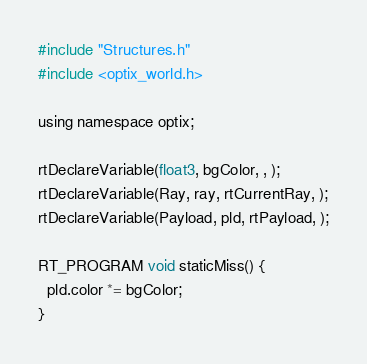<code> <loc_0><loc_0><loc_500><loc_500><_Cuda_>#include "Structures.h"
#include <optix_world.h>

using namespace optix;

rtDeclareVariable(float3, bgColor, , );
rtDeclareVariable(Ray, ray, rtCurrentRay, );
rtDeclareVariable(Payload, pld, rtPayload, );

RT_PROGRAM void staticMiss() {
  pld.color *= bgColor;
}
</code> 